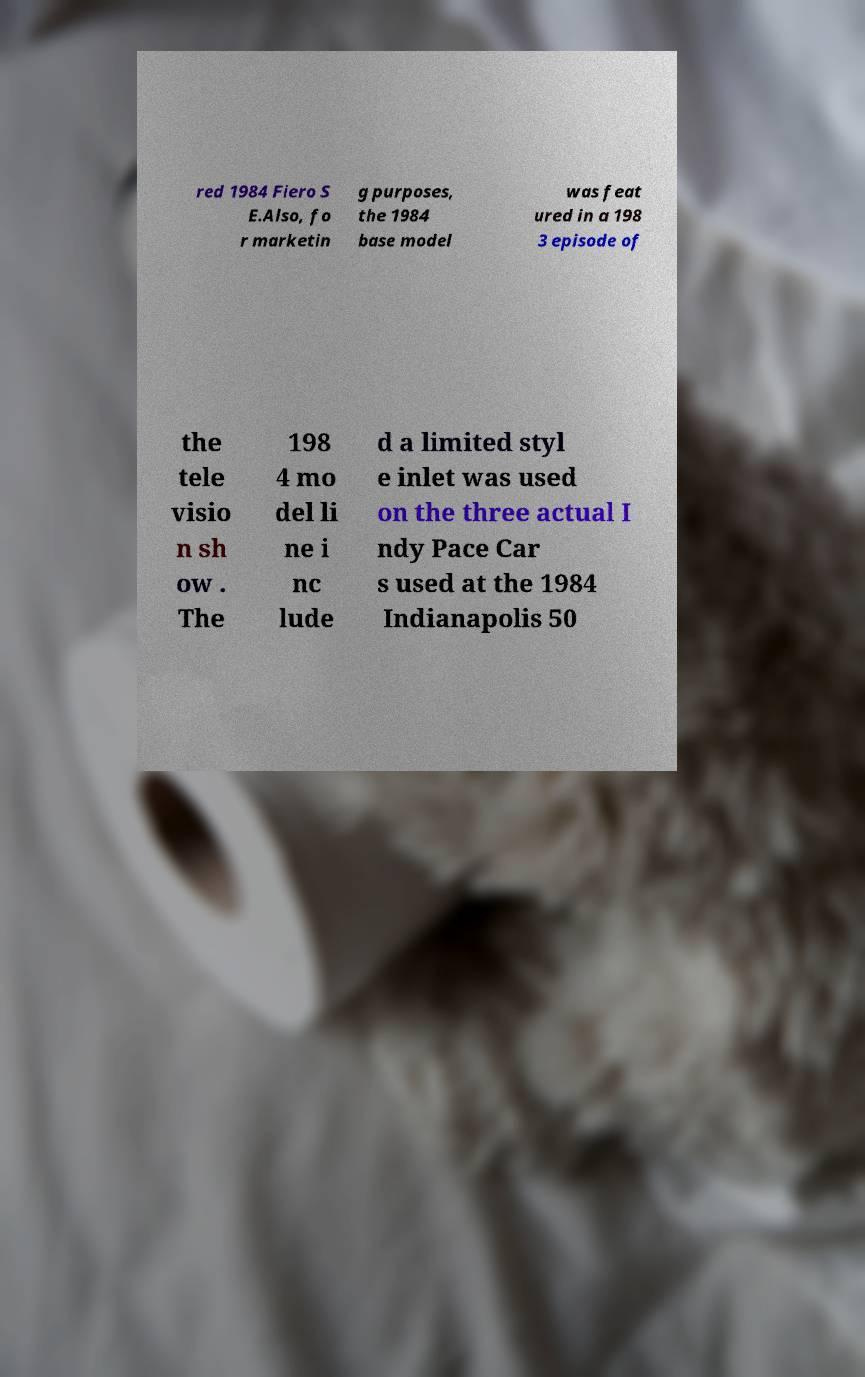Could you assist in decoding the text presented in this image and type it out clearly? red 1984 Fiero S E.Also, fo r marketin g purposes, the 1984 base model was feat ured in a 198 3 episode of the tele visio n sh ow . The 198 4 mo del li ne i nc lude d a limited styl e inlet was used on the three actual I ndy Pace Car s used at the 1984 Indianapolis 50 